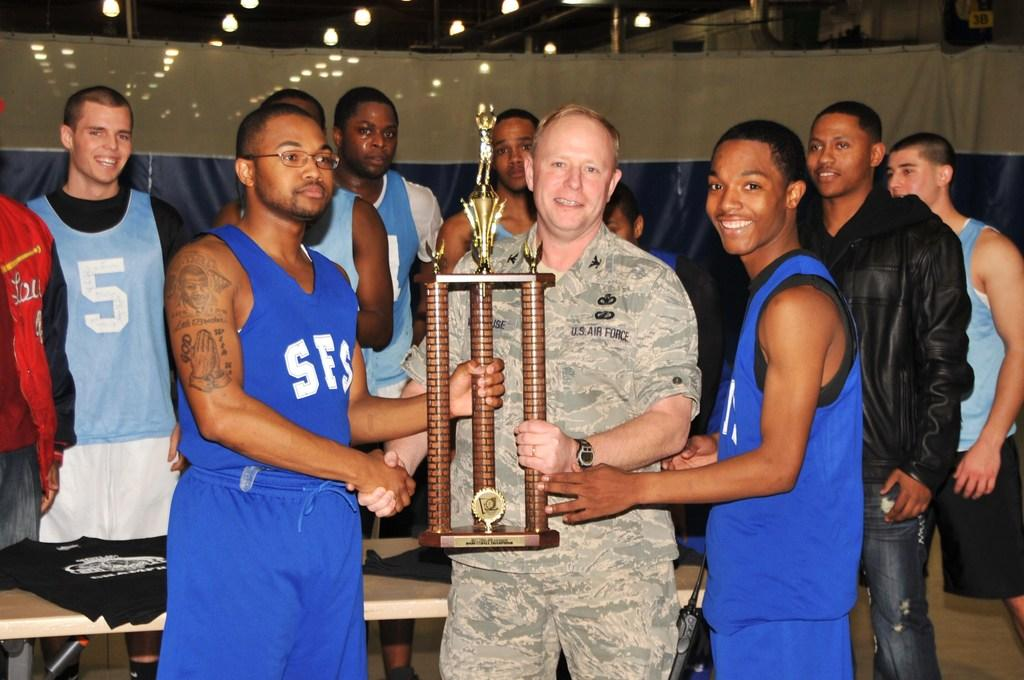<image>
Offer a succinct explanation of the picture presented. A United States Air Force Colonel and two basketball players holding a trophy. 